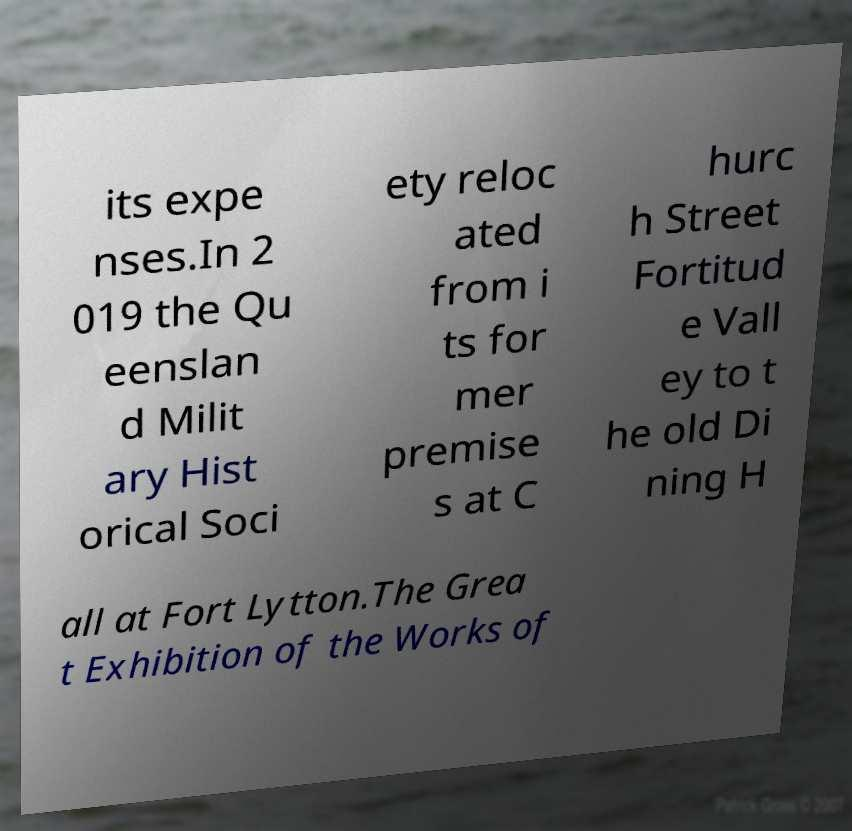What messages or text are displayed in this image? I need them in a readable, typed format. its expe nses.In 2 019 the Qu eenslan d Milit ary Hist orical Soci ety reloc ated from i ts for mer premise s at C hurc h Street Fortitud e Vall ey to t he old Di ning H all at Fort Lytton.The Grea t Exhibition of the Works of 